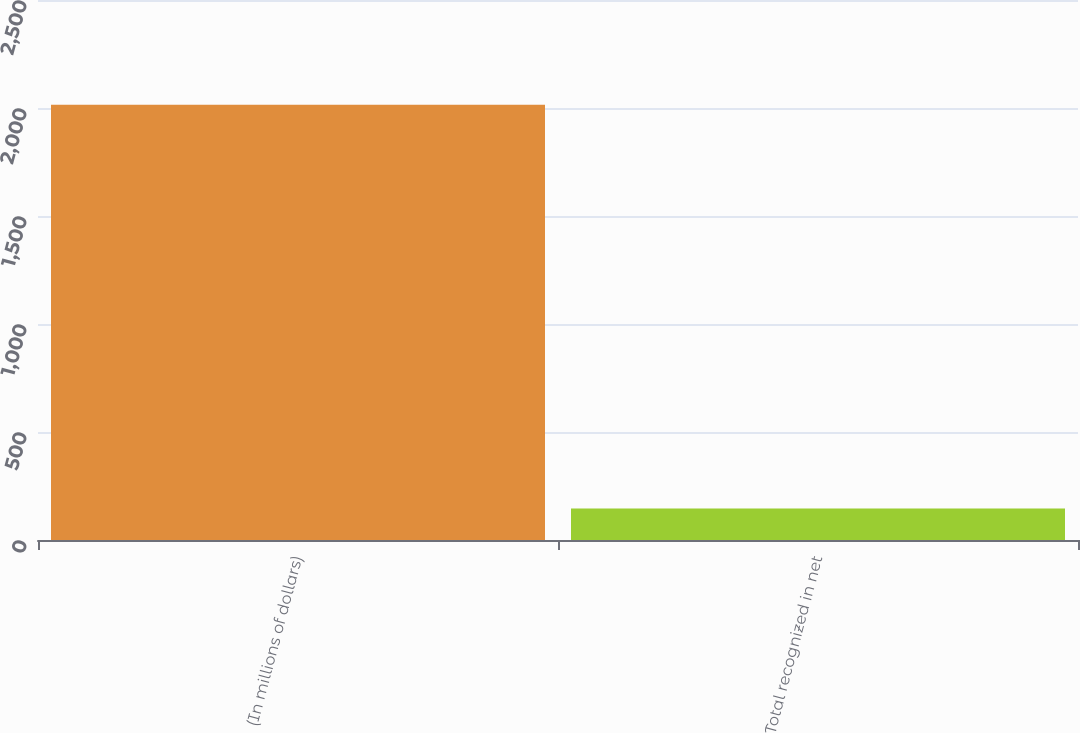Convert chart to OTSL. <chart><loc_0><loc_0><loc_500><loc_500><bar_chart><fcel>(In millions of dollars)<fcel>Total recognized in net<nl><fcel>2015<fcel>146<nl></chart> 